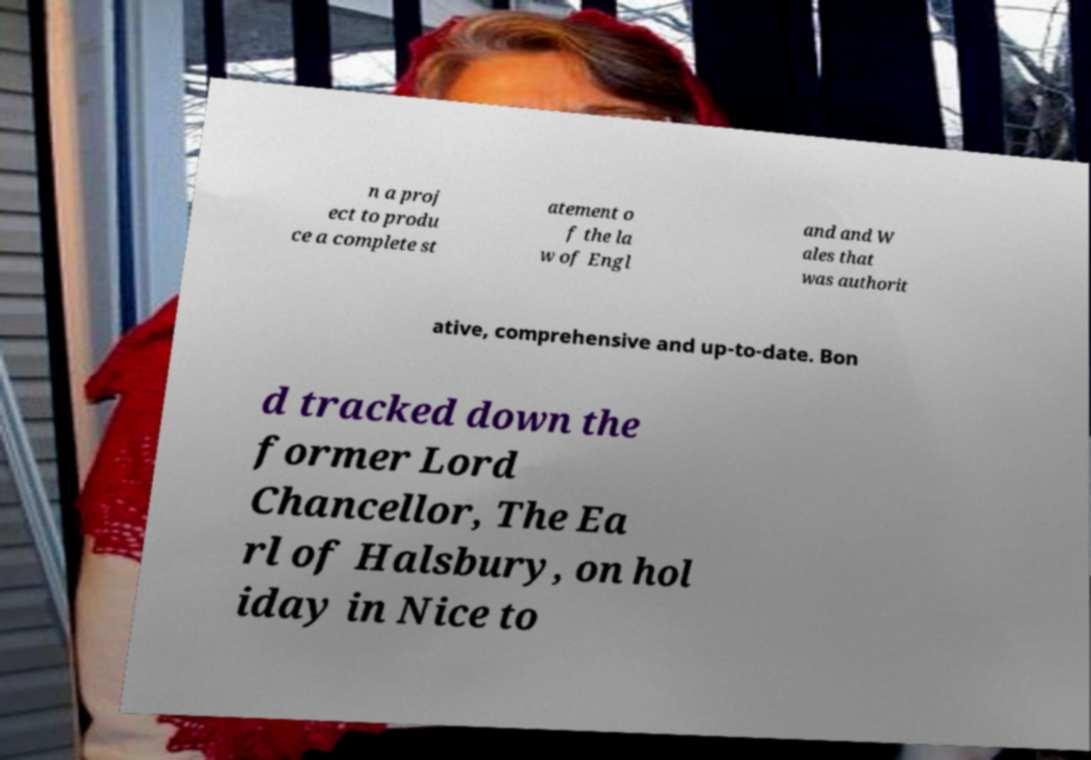There's text embedded in this image that I need extracted. Can you transcribe it verbatim? n a proj ect to produ ce a complete st atement o f the la w of Engl and and W ales that was authorit ative, comprehensive and up-to-date. Bon d tracked down the former Lord Chancellor, The Ea rl of Halsbury, on hol iday in Nice to 